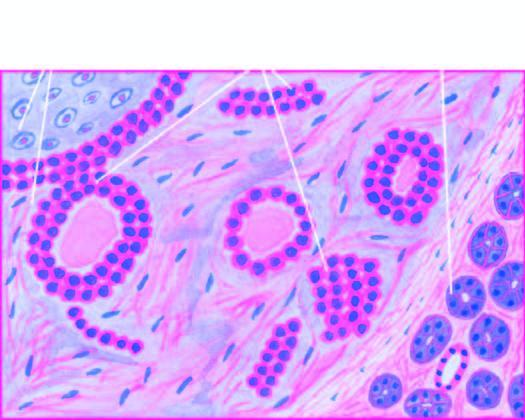what is the epithelial element comprised of?
Answer the question using a single word or phrase. Ducts 